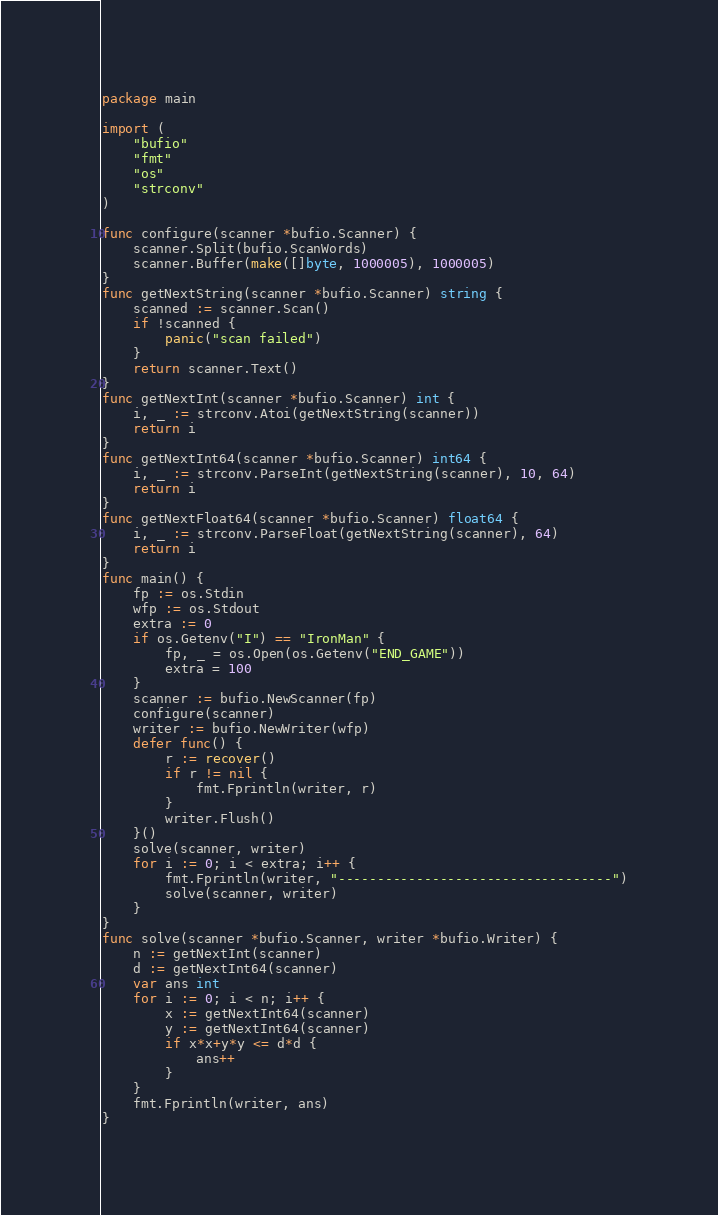<code> <loc_0><loc_0><loc_500><loc_500><_Go_>package main

import (
	"bufio"
	"fmt"
	"os"
	"strconv"
)

func configure(scanner *bufio.Scanner) {
	scanner.Split(bufio.ScanWords)
	scanner.Buffer(make([]byte, 1000005), 1000005)
}
func getNextString(scanner *bufio.Scanner) string {
	scanned := scanner.Scan()
	if !scanned {
		panic("scan failed")
	}
	return scanner.Text()
}
func getNextInt(scanner *bufio.Scanner) int {
	i, _ := strconv.Atoi(getNextString(scanner))
	return i
}
func getNextInt64(scanner *bufio.Scanner) int64 {
	i, _ := strconv.ParseInt(getNextString(scanner), 10, 64)
	return i
}
func getNextFloat64(scanner *bufio.Scanner) float64 {
	i, _ := strconv.ParseFloat(getNextString(scanner), 64)
	return i
}
func main() {
	fp := os.Stdin
	wfp := os.Stdout
	extra := 0
	if os.Getenv("I") == "IronMan" {
		fp, _ = os.Open(os.Getenv("END_GAME"))
		extra = 100
	}
	scanner := bufio.NewScanner(fp)
	configure(scanner)
	writer := bufio.NewWriter(wfp)
	defer func() {
		r := recover()
		if r != nil {
			fmt.Fprintln(writer, r)
		}
		writer.Flush()
	}()
	solve(scanner, writer)
	for i := 0; i < extra; i++ {
		fmt.Fprintln(writer, "-----------------------------------")
		solve(scanner, writer)
	}
}
func solve(scanner *bufio.Scanner, writer *bufio.Writer) {
	n := getNextInt(scanner)
	d := getNextInt64(scanner)
	var ans int
	for i := 0; i < n; i++ {
		x := getNextInt64(scanner)
		y := getNextInt64(scanner)
		if x*x+y*y <= d*d {
			ans++
		}
	}
	fmt.Fprintln(writer, ans)
}
</code> 